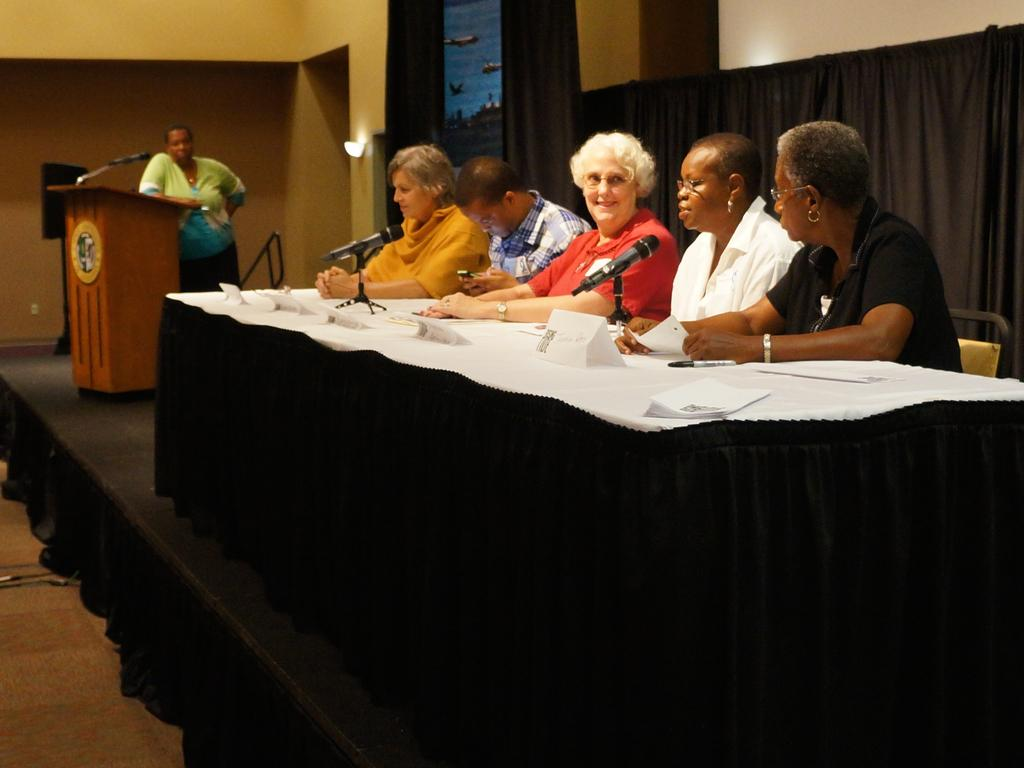What are the people in the image doing? The people in the image are sitting on chairs. Are there any other people in the image besides those sitting on chairs? Yes, there is a person standing in the image. What type of parcel is being delivered to the person standing in the image? There is no parcel visible in the image, and therefore no such delivery can be observed. What type of competition is the person standing in the image participating in? There is no competition present in the image, and the person standing is not participating in any such event. 